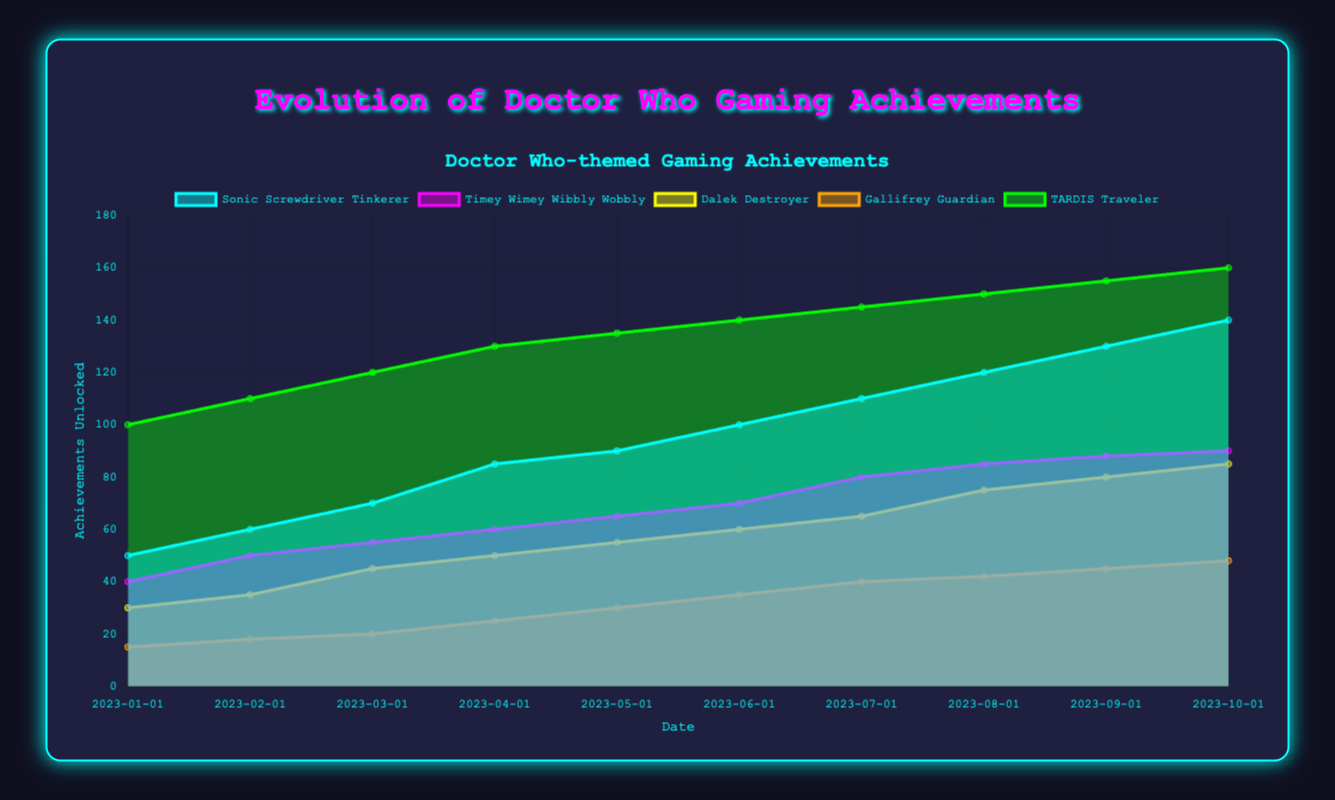What is the title of the chart? The title of the chart is located at the top and reads "Evolution of Doctor Who Gaming Achievements."
Answer: Evolution of Doctor Who Gaming Achievements How many achievements are tracked in the chart? The chart has five datasets, each representing a different achievement. This can be seen by counting the different colored areas in the chart.
Answer: Five Which achievement has the highest value in October 2023? By examining the chart at the October 2023 marker, the 'TARDIS Traveler' dataset has the highest value of 160, which is the highest point among all achievements at that date.
Answer: TARDIS Traveler How much did the 'Dalek Destroyer' increase from January 2023 to October 2023? The 'Dalek Destroyer' started at 30 in January 2023 and went up to 85 in October 2023. The increase is calculated as 85 - 30.
Answer: 55 What pattern can you observe about the 'Gallifrey Guardian' achievement over time? The 'Gallifrey Guardian' achievement consistently increases over time, with a gradual rise each month, visualized by the steadily increasing height of its area in the chart.
Answer: It increases consistently Compare the 'Timey Wimey Wibbly Wobbly' achievement in February 2023 and August 2023. In February 2023, the 'Timey Wimey Wibbly Wobbly' achievement was at 50, while in August 2023, it was at 85. The increase from February to August is calculated as 85 - 50.
Answer: 35 What is the smallest achievement value recorded in the chart for any category and at any time? Checking the first month (January 2023), 'Gallifrey Guardian' has the smallest value which is 15, smaller than the starting points of all other categories.
Answer: 15 Which achievement had the fastest growth rate between March 2023 and April 2023? By comparing the slopes between March and April 2023 for all achievements, 'Sonic Screwdriver Tinkerer' increased from 70 to 85, which is a jump of 15, the fastest among all the achievements.
Answer: Sonic Screwdriver Tinkerer What is the total number of 'TARDIS Traveler' achievements unlocked by July 2023? Summing up the 'TARDIS Traveler' achievements from January to July (inclusive): 100 + 110 + 120 + 130 + 135 + 140 + 145 = 880.
Answer: 880 How did the 'Sonic Screwdriver Tinkerer' achievement perform compared to 'Dalek Destroyer' in June 2023? In June 2023, 'Sonic Screwdriver Tinkerer' achievements were at 100, while 'Dalek Destroyer' achievements were at 60. So, 'Sonic Screwdriver Tinkerer' performed better as it had a higher value.
Answer: Better 